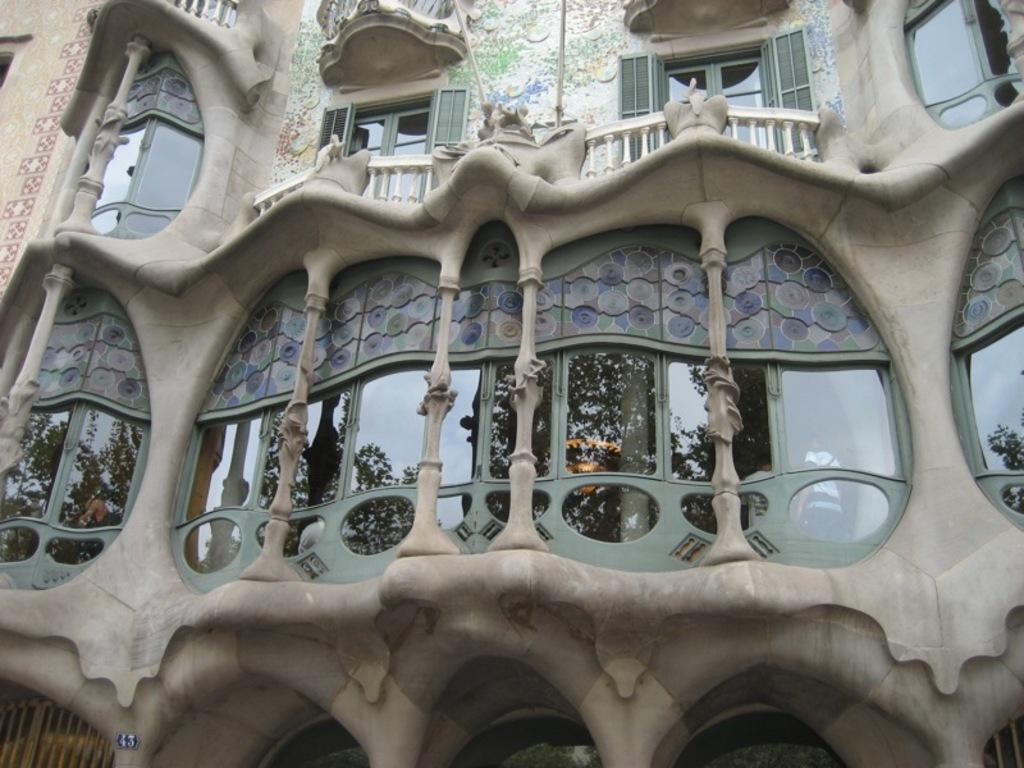What is the main structure in the image? There is a building in the image. What feature can be seen on the building? The building has windows. Can you tell me how many answers are visible in the stream near the building? There is no stream or answers present in the image; it only features a building with windows. 